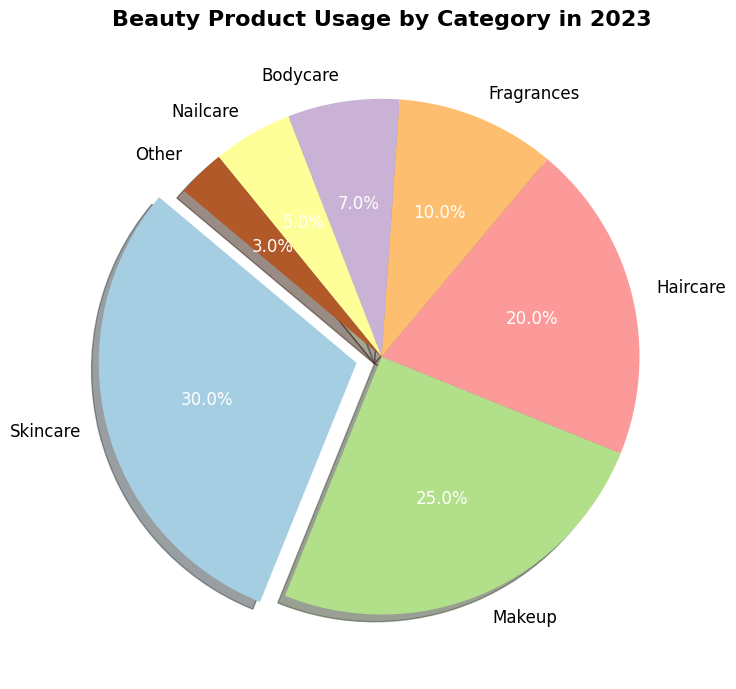what's the largest category in the pie chart? Look at the slices of the pie chart and identify the one with the largest size. The largest slice represents the category with the highest percentage, which is Skincare at 30%.
Answer: Skincare which two categories together make up more than half of the total beauty product usage? Add the percentages of the two largest categories. Skincare is 30% and Makeup is 25%. If we add these together (30 + 25 = 55), they make up more than half of the total.
Answer: Skincare and Makeup how much more popular is Haircare compared to Nailcare? Find the percentages of Haircare and Nailcare in the pie chart. Haircare is 20% and Nailcare is 5%. Subtract Nailcare's percentage from Haircare's percentage (20 - 5 = 15). Haircare is 15% more popular.
Answer: 15% which categories have less usage than Fragrances? Look at the pie chart and compare the slices. Fragrances have 10% usage. Identify all categories smaller than this: Bodycare (7%), Nailcare (5%), and Other (3%).
Answer: Bodycare, Nailcare, and Other if you combine the three smallest categories, what percentage of the total does it represent? Identify the percentages of the three smallest categories: Bodycare (7%), Nailcare (5%), and Other (3%). Add these together (7 + 5 + 3 = 15). The combined percentage is 15%.
Answer: 15% what category is represented by the slice that is exploded outwards? Identify the slice in the pie chart that is separated outwards. The exploded slice is Skincare, indicating emphasis on this category.
Answer: Skincare what's the difference in percentage use between the largest and smallest categories? Identify the largest category (Skincare at 30%) and the smallest category (Other at 3%). Subtract the smallest from the largest (30 - 3 = 27). The difference is 27%.
Answer: 27% 